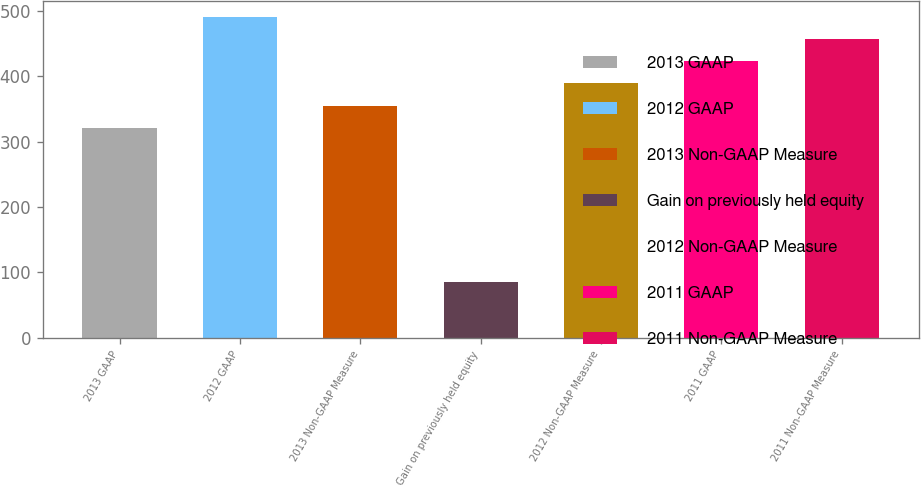Convert chart to OTSL. <chart><loc_0><loc_0><loc_500><loc_500><bar_chart><fcel>2013 GAAP<fcel>2012 GAAP<fcel>2013 Non-GAAP Measure<fcel>Gain on previously held equity<fcel>2012 Non-GAAP Measure<fcel>2011 GAAP<fcel>2011 Non-GAAP Measure<nl><fcel>321.3<fcel>491.15<fcel>355.27<fcel>85.9<fcel>389.24<fcel>423.21<fcel>457.18<nl></chart> 